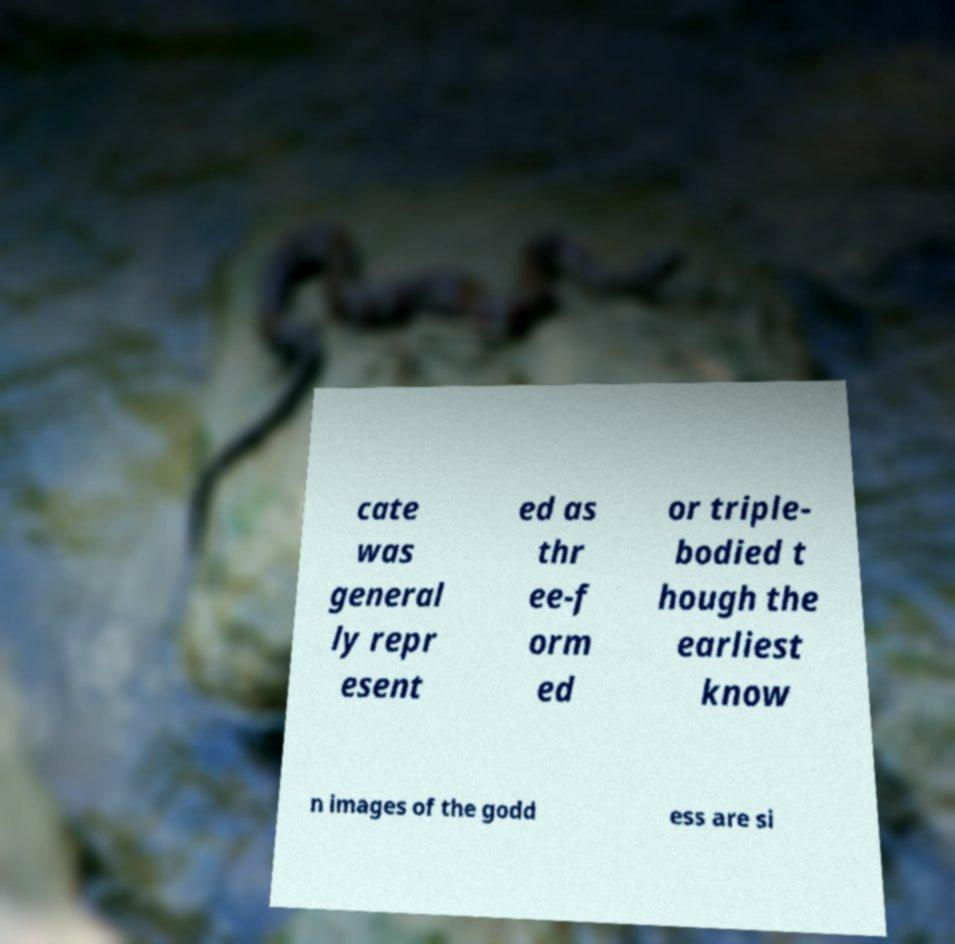What messages or text are displayed in this image? I need them in a readable, typed format. cate was general ly repr esent ed as thr ee-f orm ed or triple- bodied t hough the earliest know n images of the godd ess are si 